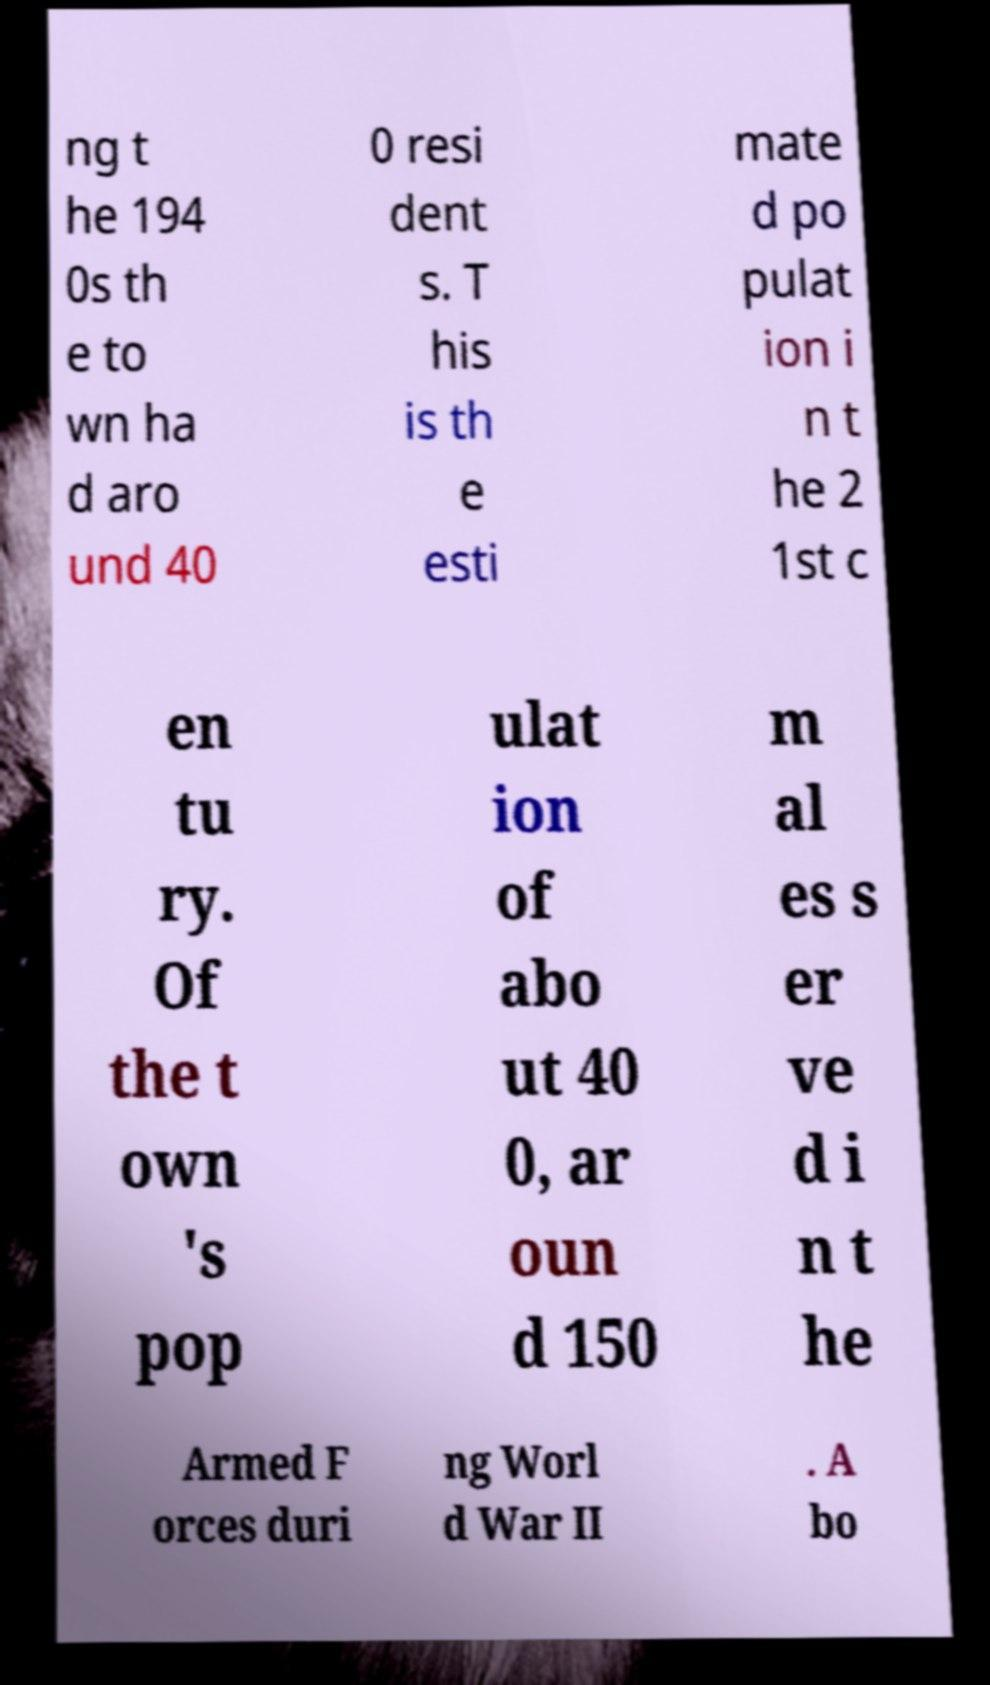Can you accurately transcribe the text from the provided image for me? ng t he 194 0s th e to wn ha d aro und 40 0 resi dent s. T his is th e esti mate d po pulat ion i n t he 2 1st c en tu ry. Of the t own 's pop ulat ion of abo ut 40 0, ar oun d 150 m al es s er ve d i n t he Armed F orces duri ng Worl d War II . A bo 